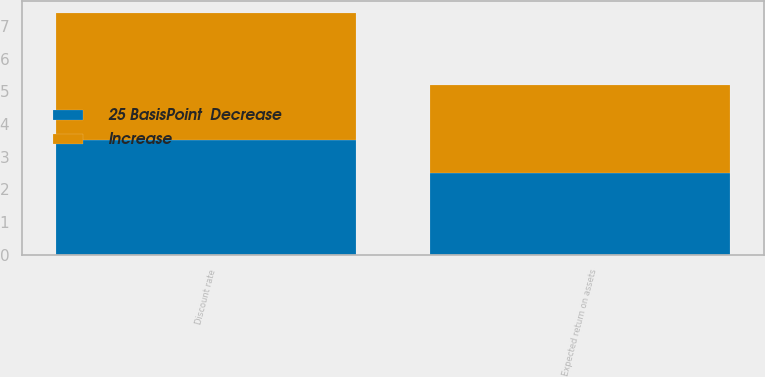Convert chart. <chart><loc_0><loc_0><loc_500><loc_500><stacked_bar_chart><ecel><fcel>Discount rate<fcel>Expected return on assets<nl><fcel>25 BasisPoint  Decrease<fcel>3.5<fcel>2.5<nl><fcel>Increase<fcel>3.9<fcel>2.7<nl></chart> 